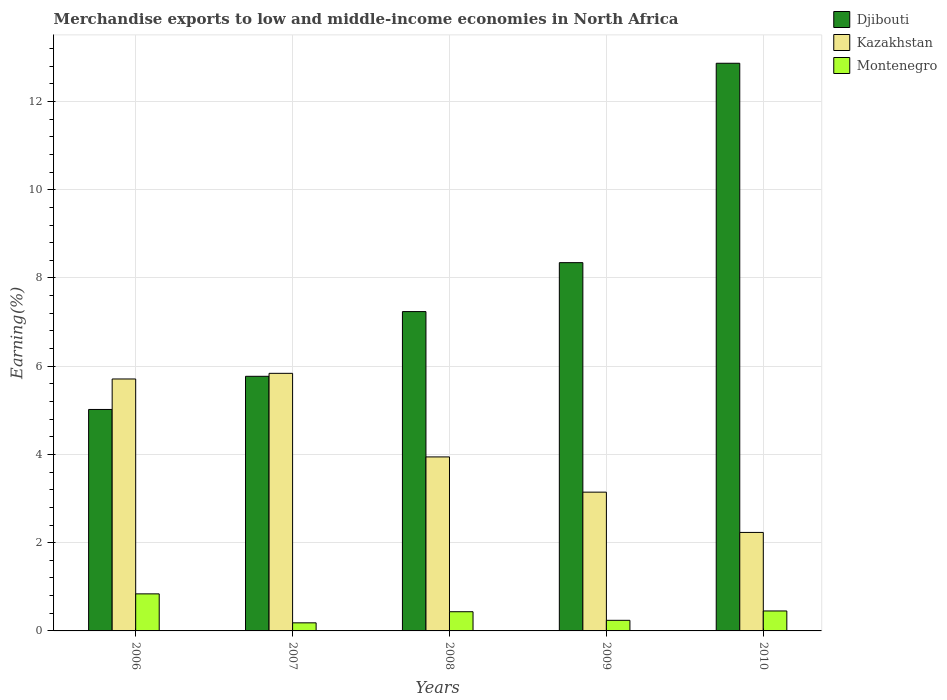How many bars are there on the 5th tick from the left?
Give a very brief answer. 3. How many bars are there on the 1st tick from the right?
Provide a succinct answer. 3. In how many cases, is the number of bars for a given year not equal to the number of legend labels?
Provide a short and direct response. 0. What is the percentage of amount earned from merchandise exports in Montenegro in 2010?
Provide a short and direct response. 0.45. Across all years, what is the maximum percentage of amount earned from merchandise exports in Kazakhstan?
Give a very brief answer. 5.84. Across all years, what is the minimum percentage of amount earned from merchandise exports in Kazakhstan?
Ensure brevity in your answer.  2.23. In which year was the percentage of amount earned from merchandise exports in Kazakhstan minimum?
Keep it short and to the point. 2010. What is the total percentage of amount earned from merchandise exports in Kazakhstan in the graph?
Ensure brevity in your answer.  20.87. What is the difference between the percentage of amount earned from merchandise exports in Djibouti in 2008 and that in 2009?
Provide a succinct answer. -1.11. What is the difference between the percentage of amount earned from merchandise exports in Kazakhstan in 2007 and the percentage of amount earned from merchandise exports in Djibouti in 2008?
Your response must be concise. -1.4. What is the average percentage of amount earned from merchandise exports in Kazakhstan per year?
Offer a terse response. 4.17. In the year 2007, what is the difference between the percentage of amount earned from merchandise exports in Djibouti and percentage of amount earned from merchandise exports in Montenegro?
Give a very brief answer. 5.59. What is the ratio of the percentage of amount earned from merchandise exports in Kazakhstan in 2006 to that in 2007?
Provide a succinct answer. 0.98. What is the difference between the highest and the second highest percentage of amount earned from merchandise exports in Montenegro?
Your answer should be compact. 0.39. What is the difference between the highest and the lowest percentage of amount earned from merchandise exports in Djibouti?
Provide a short and direct response. 7.85. Is the sum of the percentage of amount earned from merchandise exports in Kazakhstan in 2008 and 2009 greater than the maximum percentage of amount earned from merchandise exports in Montenegro across all years?
Offer a terse response. Yes. What does the 3rd bar from the left in 2006 represents?
Your response must be concise. Montenegro. What does the 2nd bar from the right in 2009 represents?
Your answer should be very brief. Kazakhstan. How many bars are there?
Offer a very short reply. 15. Are all the bars in the graph horizontal?
Provide a succinct answer. No. What is the difference between two consecutive major ticks on the Y-axis?
Your response must be concise. 2. Are the values on the major ticks of Y-axis written in scientific E-notation?
Your response must be concise. No. Does the graph contain any zero values?
Give a very brief answer. No. Where does the legend appear in the graph?
Offer a very short reply. Top right. How are the legend labels stacked?
Provide a succinct answer. Vertical. What is the title of the graph?
Give a very brief answer. Merchandise exports to low and middle-income economies in North Africa. What is the label or title of the X-axis?
Your answer should be compact. Years. What is the label or title of the Y-axis?
Keep it short and to the point. Earning(%). What is the Earning(%) of Djibouti in 2006?
Provide a short and direct response. 5.02. What is the Earning(%) of Kazakhstan in 2006?
Your answer should be very brief. 5.71. What is the Earning(%) of Montenegro in 2006?
Keep it short and to the point. 0.84. What is the Earning(%) in Djibouti in 2007?
Give a very brief answer. 5.77. What is the Earning(%) of Kazakhstan in 2007?
Your answer should be very brief. 5.84. What is the Earning(%) of Montenegro in 2007?
Your response must be concise. 0.18. What is the Earning(%) of Djibouti in 2008?
Your response must be concise. 7.24. What is the Earning(%) in Kazakhstan in 2008?
Ensure brevity in your answer.  3.94. What is the Earning(%) in Montenegro in 2008?
Your answer should be compact. 0.43. What is the Earning(%) in Djibouti in 2009?
Offer a very short reply. 8.35. What is the Earning(%) of Kazakhstan in 2009?
Offer a terse response. 3.15. What is the Earning(%) of Montenegro in 2009?
Make the answer very short. 0.24. What is the Earning(%) of Djibouti in 2010?
Offer a terse response. 12.87. What is the Earning(%) of Kazakhstan in 2010?
Make the answer very short. 2.23. What is the Earning(%) of Montenegro in 2010?
Offer a terse response. 0.45. Across all years, what is the maximum Earning(%) of Djibouti?
Keep it short and to the point. 12.87. Across all years, what is the maximum Earning(%) of Kazakhstan?
Offer a very short reply. 5.84. Across all years, what is the maximum Earning(%) in Montenegro?
Ensure brevity in your answer.  0.84. Across all years, what is the minimum Earning(%) of Djibouti?
Keep it short and to the point. 5.02. Across all years, what is the minimum Earning(%) in Kazakhstan?
Your response must be concise. 2.23. Across all years, what is the minimum Earning(%) in Montenegro?
Make the answer very short. 0.18. What is the total Earning(%) of Djibouti in the graph?
Provide a succinct answer. 39.24. What is the total Earning(%) of Kazakhstan in the graph?
Your answer should be compact. 20.87. What is the total Earning(%) of Montenegro in the graph?
Make the answer very short. 2.15. What is the difference between the Earning(%) in Djibouti in 2006 and that in 2007?
Provide a succinct answer. -0.75. What is the difference between the Earning(%) in Kazakhstan in 2006 and that in 2007?
Offer a very short reply. -0.13. What is the difference between the Earning(%) of Montenegro in 2006 and that in 2007?
Make the answer very short. 0.66. What is the difference between the Earning(%) of Djibouti in 2006 and that in 2008?
Provide a short and direct response. -2.22. What is the difference between the Earning(%) in Kazakhstan in 2006 and that in 2008?
Provide a short and direct response. 1.77. What is the difference between the Earning(%) in Montenegro in 2006 and that in 2008?
Offer a terse response. 0.4. What is the difference between the Earning(%) of Djibouti in 2006 and that in 2009?
Offer a very short reply. -3.33. What is the difference between the Earning(%) in Kazakhstan in 2006 and that in 2009?
Make the answer very short. 2.56. What is the difference between the Earning(%) in Montenegro in 2006 and that in 2009?
Offer a terse response. 0.6. What is the difference between the Earning(%) in Djibouti in 2006 and that in 2010?
Your answer should be very brief. -7.85. What is the difference between the Earning(%) in Kazakhstan in 2006 and that in 2010?
Keep it short and to the point. 3.48. What is the difference between the Earning(%) in Montenegro in 2006 and that in 2010?
Give a very brief answer. 0.39. What is the difference between the Earning(%) in Djibouti in 2007 and that in 2008?
Give a very brief answer. -1.47. What is the difference between the Earning(%) of Kazakhstan in 2007 and that in 2008?
Make the answer very short. 1.89. What is the difference between the Earning(%) in Montenegro in 2007 and that in 2008?
Provide a succinct answer. -0.25. What is the difference between the Earning(%) of Djibouti in 2007 and that in 2009?
Offer a terse response. -2.58. What is the difference between the Earning(%) in Kazakhstan in 2007 and that in 2009?
Your answer should be very brief. 2.69. What is the difference between the Earning(%) of Montenegro in 2007 and that in 2009?
Keep it short and to the point. -0.06. What is the difference between the Earning(%) in Djibouti in 2007 and that in 2010?
Your answer should be very brief. -7.1. What is the difference between the Earning(%) in Kazakhstan in 2007 and that in 2010?
Ensure brevity in your answer.  3.61. What is the difference between the Earning(%) of Montenegro in 2007 and that in 2010?
Your answer should be very brief. -0.27. What is the difference between the Earning(%) in Djibouti in 2008 and that in 2009?
Provide a short and direct response. -1.11. What is the difference between the Earning(%) of Kazakhstan in 2008 and that in 2009?
Provide a succinct answer. 0.8. What is the difference between the Earning(%) in Montenegro in 2008 and that in 2009?
Your answer should be compact. 0.19. What is the difference between the Earning(%) of Djibouti in 2008 and that in 2010?
Ensure brevity in your answer.  -5.63. What is the difference between the Earning(%) in Kazakhstan in 2008 and that in 2010?
Your answer should be compact. 1.71. What is the difference between the Earning(%) in Montenegro in 2008 and that in 2010?
Offer a very short reply. -0.02. What is the difference between the Earning(%) of Djibouti in 2009 and that in 2010?
Provide a short and direct response. -4.52. What is the difference between the Earning(%) in Kazakhstan in 2009 and that in 2010?
Your answer should be very brief. 0.91. What is the difference between the Earning(%) of Montenegro in 2009 and that in 2010?
Your answer should be compact. -0.21. What is the difference between the Earning(%) in Djibouti in 2006 and the Earning(%) in Kazakhstan in 2007?
Give a very brief answer. -0.82. What is the difference between the Earning(%) in Djibouti in 2006 and the Earning(%) in Montenegro in 2007?
Offer a terse response. 4.84. What is the difference between the Earning(%) of Kazakhstan in 2006 and the Earning(%) of Montenegro in 2007?
Your answer should be compact. 5.53. What is the difference between the Earning(%) of Djibouti in 2006 and the Earning(%) of Kazakhstan in 2008?
Give a very brief answer. 1.08. What is the difference between the Earning(%) of Djibouti in 2006 and the Earning(%) of Montenegro in 2008?
Your answer should be very brief. 4.58. What is the difference between the Earning(%) of Kazakhstan in 2006 and the Earning(%) of Montenegro in 2008?
Make the answer very short. 5.28. What is the difference between the Earning(%) in Djibouti in 2006 and the Earning(%) in Kazakhstan in 2009?
Your response must be concise. 1.87. What is the difference between the Earning(%) in Djibouti in 2006 and the Earning(%) in Montenegro in 2009?
Provide a succinct answer. 4.78. What is the difference between the Earning(%) in Kazakhstan in 2006 and the Earning(%) in Montenegro in 2009?
Offer a terse response. 5.47. What is the difference between the Earning(%) in Djibouti in 2006 and the Earning(%) in Kazakhstan in 2010?
Make the answer very short. 2.79. What is the difference between the Earning(%) of Djibouti in 2006 and the Earning(%) of Montenegro in 2010?
Make the answer very short. 4.57. What is the difference between the Earning(%) of Kazakhstan in 2006 and the Earning(%) of Montenegro in 2010?
Provide a short and direct response. 5.26. What is the difference between the Earning(%) of Djibouti in 2007 and the Earning(%) of Kazakhstan in 2008?
Provide a short and direct response. 1.83. What is the difference between the Earning(%) in Djibouti in 2007 and the Earning(%) in Montenegro in 2008?
Offer a very short reply. 5.34. What is the difference between the Earning(%) of Kazakhstan in 2007 and the Earning(%) of Montenegro in 2008?
Ensure brevity in your answer.  5.4. What is the difference between the Earning(%) of Djibouti in 2007 and the Earning(%) of Kazakhstan in 2009?
Offer a very short reply. 2.63. What is the difference between the Earning(%) of Djibouti in 2007 and the Earning(%) of Montenegro in 2009?
Ensure brevity in your answer.  5.53. What is the difference between the Earning(%) in Kazakhstan in 2007 and the Earning(%) in Montenegro in 2009?
Your response must be concise. 5.6. What is the difference between the Earning(%) in Djibouti in 2007 and the Earning(%) in Kazakhstan in 2010?
Keep it short and to the point. 3.54. What is the difference between the Earning(%) of Djibouti in 2007 and the Earning(%) of Montenegro in 2010?
Your response must be concise. 5.32. What is the difference between the Earning(%) in Kazakhstan in 2007 and the Earning(%) in Montenegro in 2010?
Give a very brief answer. 5.39. What is the difference between the Earning(%) in Djibouti in 2008 and the Earning(%) in Kazakhstan in 2009?
Offer a very short reply. 4.09. What is the difference between the Earning(%) of Djibouti in 2008 and the Earning(%) of Montenegro in 2009?
Make the answer very short. 7. What is the difference between the Earning(%) in Kazakhstan in 2008 and the Earning(%) in Montenegro in 2009?
Provide a succinct answer. 3.7. What is the difference between the Earning(%) of Djibouti in 2008 and the Earning(%) of Kazakhstan in 2010?
Your answer should be very brief. 5.01. What is the difference between the Earning(%) of Djibouti in 2008 and the Earning(%) of Montenegro in 2010?
Keep it short and to the point. 6.79. What is the difference between the Earning(%) of Kazakhstan in 2008 and the Earning(%) of Montenegro in 2010?
Ensure brevity in your answer.  3.49. What is the difference between the Earning(%) in Djibouti in 2009 and the Earning(%) in Kazakhstan in 2010?
Offer a very short reply. 6.11. What is the difference between the Earning(%) in Djibouti in 2009 and the Earning(%) in Montenegro in 2010?
Provide a succinct answer. 7.89. What is the difference between the Earning(%) of Kazakhstan in 2009 and the Earning(%) of Montenegro in 2010?
Your answer should be very brief. 2.69. What is the average Earning(%) in Djibouti per year?
Your answer should be very brief. 7.85. What is the average Earning(%) in Kazakhstan per year?
Keep it short and to the point. 4.17. What is the average Earning(%) of Montenegro per year?
Make the answer very short. 0.43. In the year 2006, what is the difference between the Earning(%) in Djibouti and Earning(%) in Kazakhstan?
Keep it short and to the point. -0.69. In the year 2006, what is the difference between the Earning(%) in Djibouti and Earning(%) in Montenegro?
Offer a terse response. 4.18. In the year 2006, what is the difference between the Earning(%) of Kazakhstan and Earning(%) of Montenegro?
Offer a terse response. 4.87. In the year 2007, what is the difference between the Earning(%) in Djibouti and Earning(%) in Kazakhstan?
Your answer should be very brief. -0.07. In the year 2007, what is the difference between the Earning(%) of Djibouti and Earning(%) of Montenegro?
Ensure brevity in your answer.  5.59. In the year 2007, what is the difference between the Earning(%) of Kazakhstan and Earning(%) of Montenegro?
Your response must be concise. 5.65. In the year 2008, what is the difference between the Earning(%) of Djibouti and Earning(%) of Kazakhstan?
Offer a very short reply. 3.29. In the year 2008, what is the difference between the Earning(%) of Djibouti and Earning(%) of Montenegro?
Offer a very short reply. 6.8. In the year 2008, what is the difference between the Earning(%) in Kazakhstan and Earning(%) in Montenegro?
Provide a short and direct response. 3.51. In the year 2009, what is the difference between the Earning(%) in Djibouti and Earning(%) in Kazakhstan?
Offer a very short reply. 5.2. In the year 2009, what is the difference between the Earning(%) of Djibouti and Earning(%) of Montenegro?
Offer a very short reply. 8.11. In the year 2009, what is the difference between the Earning(%) of Kazakhstan and Earning(%) of Montenegro?
Provide a succinct answer. 2.9. In the year 2010, what is the difference between the Earning(%) of Djibouti and Earning(%) of Kazakhstan?
Make the answer very short. 10.63. In the year 2010, what is the difference between the Earning(%) of Djibouti and Earning(%) of Montenegro?
Offer a terse response. 12.41. In the year 2010, what is the difference between the Earning(%) in Kazakhstan and Earning(%) in Montenegro?
Make the answer very short. 1.78. What is the ratio of the Earning(%) in Djibouti in 2006 to that in 2007?
Give a very brief answer. 0.87. What is the ratio of the Earning(%) in Kazakhstan in 2006 to that in 2007?
Offer a terse response. 0.98. What is the ratio of the Earning(%) of Montenegro in 2006 to that in 2007?
Offer a very short reply. 4.58. What is the ratio of the Earning(%) in Djibouti in 2006 to that in 2008?
Offer a terse response. 0.69. What is the ratio of the Earning(%) in Kazakhstan in 2006 to that in 2008?
Offer a terse response. 1.45. What is the ratio of the Earning(%) in Montenegro in 2006 to that in 2008?
Your response must be concise. 1.93. What is the ratio of the Earning(%) of Djibouti in 2006 to that in 2009?
Give a very brief answer. 0.6. What is the ratio of the Earning(%) in Kazakhstan in 2006 to that in 2009?
Your response must be concise. 1.82. What is the ratio of the Earning(%) of Montenegro in 2006 to that in 2009?
Provide a short and direct response. 3.49. What is the ratio of the Earning(%) in Djibouti in 2006 to that in 2010?
Offer a terse response. 0.39. What is the ratio of the Earning(%) in Kazakhstan in 2006 to that in 2010?
Provide a succinct answer. 2.56. What is the ratio of the Earning(%) in Montenegro in 2006 to that in 2010?
Your answer should be compact. 1.86. What is the ratio of the Earning(%) in Djibouti in 2007 to that in 2008?
Your response must be concise. 0.8. What is the ratio of the Earning(%) of Kazakhstan in 2007 to that in 2008?
Offer a very short reply. 1.48. What is the ratio of the Earning(%) of Montenegro in 2007 to that in 2008?
Ensure brevity in your answer.  0.42. What is the ratio of the Earning(%) in Djibouti in 2007 to that in 2009?
Make the answer very short. 0.69. What is the ratio of the Earning(%) in Kazakhstan in 2007 to that in 2009?
Make the answer very short. 1.86. What is the ratio of the Earning(%) in Montenegro in 2007 to that in 2009?
Provide a short and direct response. 0.76. What is the ratio of the Earning(%) in Djibouti in 2007 to that in 2010?
Your answer should be compact. 0.45. What is the ratio of the Earning(%) of Kazakhstan in 2007 to that in 2010?
Offer a very short reply. 2.62. What is the ratio of the Earning(%) in Montenegro in 2007 to that in 2010?
Offer a terse response. 0.41. What is the ratio of the Earning(%) of Djibouti in 2008 to that in 2009?
Give a very brief answer. 0.87. What is the ratio of the Earning(%) in Kazakhstan in 2008 to that in 2009?
Ensure brevity in your answer.  1.25. What is the ratio of the Earning(%) in Montenegro in 2008 to that in 2009?
Offer a very short reply. 1.81. What is the ratio of the Earning(%) of Djibouti in 2008 to that in 2010?
Offer a very short reply. 0.56. What is the ratio of the Earning(%) of Kazakhstan in 2008 to that in 2010?
Offer a terse response. 1.77. What is the ratio of the Earning(%) in Montenegro in 2008 to that in 2010?
Your answer should be compact. 0.96. What is the ratio of the Earning(%) of Djibouti in 2009 to that in 2010?
Offer a very short reply. 0.65. What is the ratio of the Earning(%) in Kazakhstan in 2009 to that in 2010?
Your answer should be very brief. 1.41. What is the ratio of the Earning(%) of Montenegro in 2009 to that in 2010?
Your answer should be very brief. 0.53. What is the difference between the highest and the second highest Earning(%) in Djibouti?
Give a very brief answer. 4.52. What is the difference between the highest and the second highest Earning(%) in Kazakhstan?
Your response must be concise. 0.13. What is the difference between the highest and the second highest Earning(%) in Montenegro?
Make the answer very short. 0.39. What is the difference between the highest and the lowest Earning(%) in Djibouti?
Offer a terse response. 7.85. What is the difference between the highest and the lowest Earning(%) of Kazakhstan?
Your response must be concise. 3.61. What is the difference between the highest and the lowest Earning(%) of Montenegro?
Offer a terse response. 0.66. 